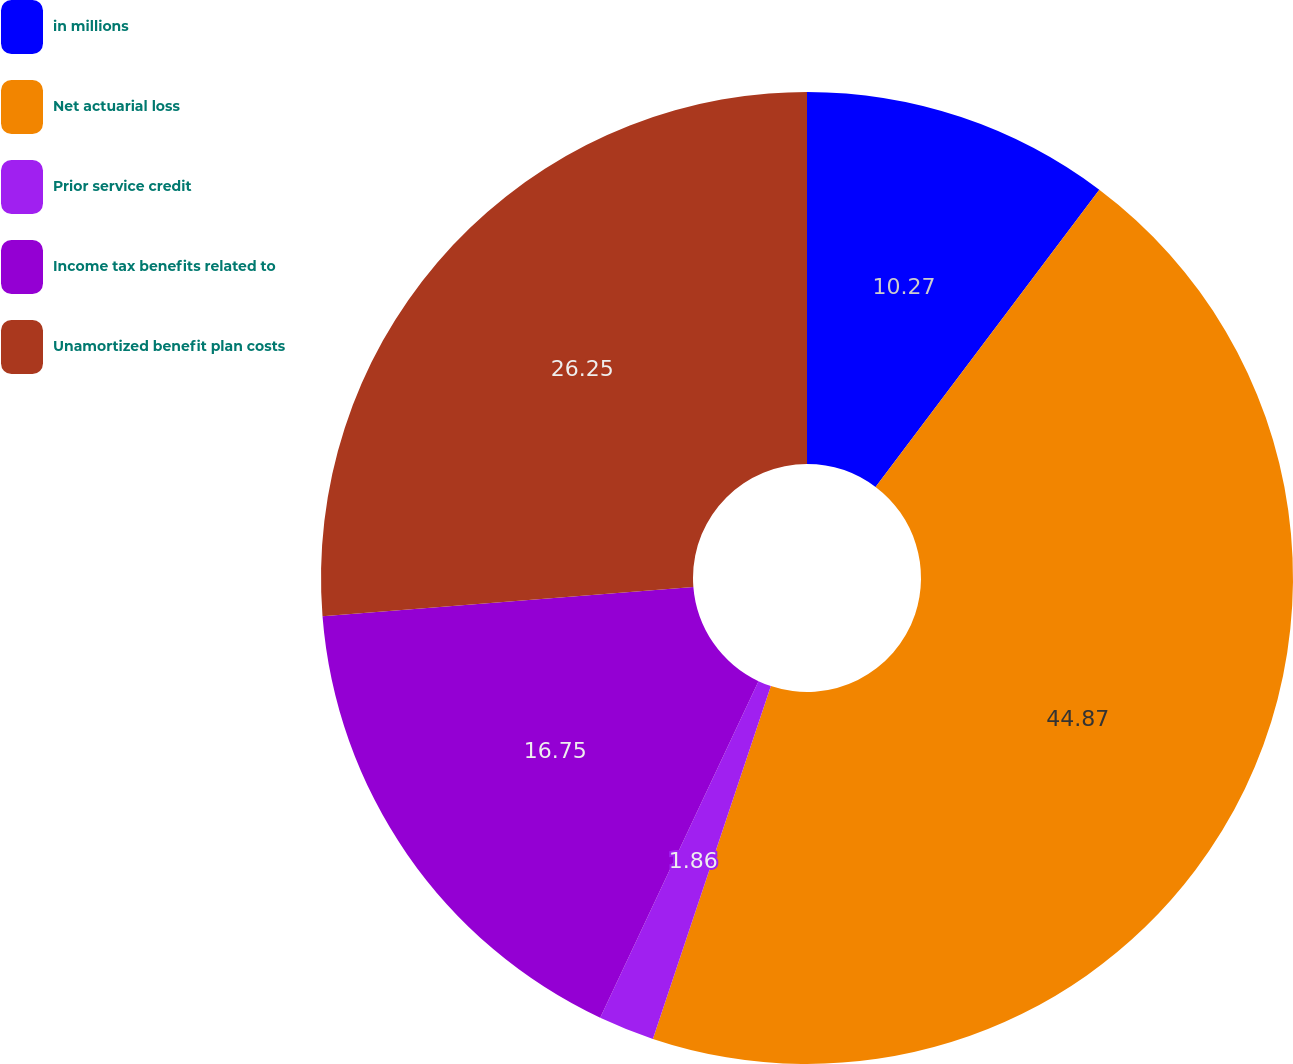Convert chart. <chart><loc_0><loc_0><loc_500><loc_500><pie_chart><fcel>in millions<fcel>Net actuarial loss<fcel>Prior service credit<fcel>Income tax benefits related to<fcel>Unamortized benefit plan costs<nl><fcel>10.27%<fcel>44.86%<fcel>1.86%<fcel>16.75%<fcel>26.25%<nl></chart> 